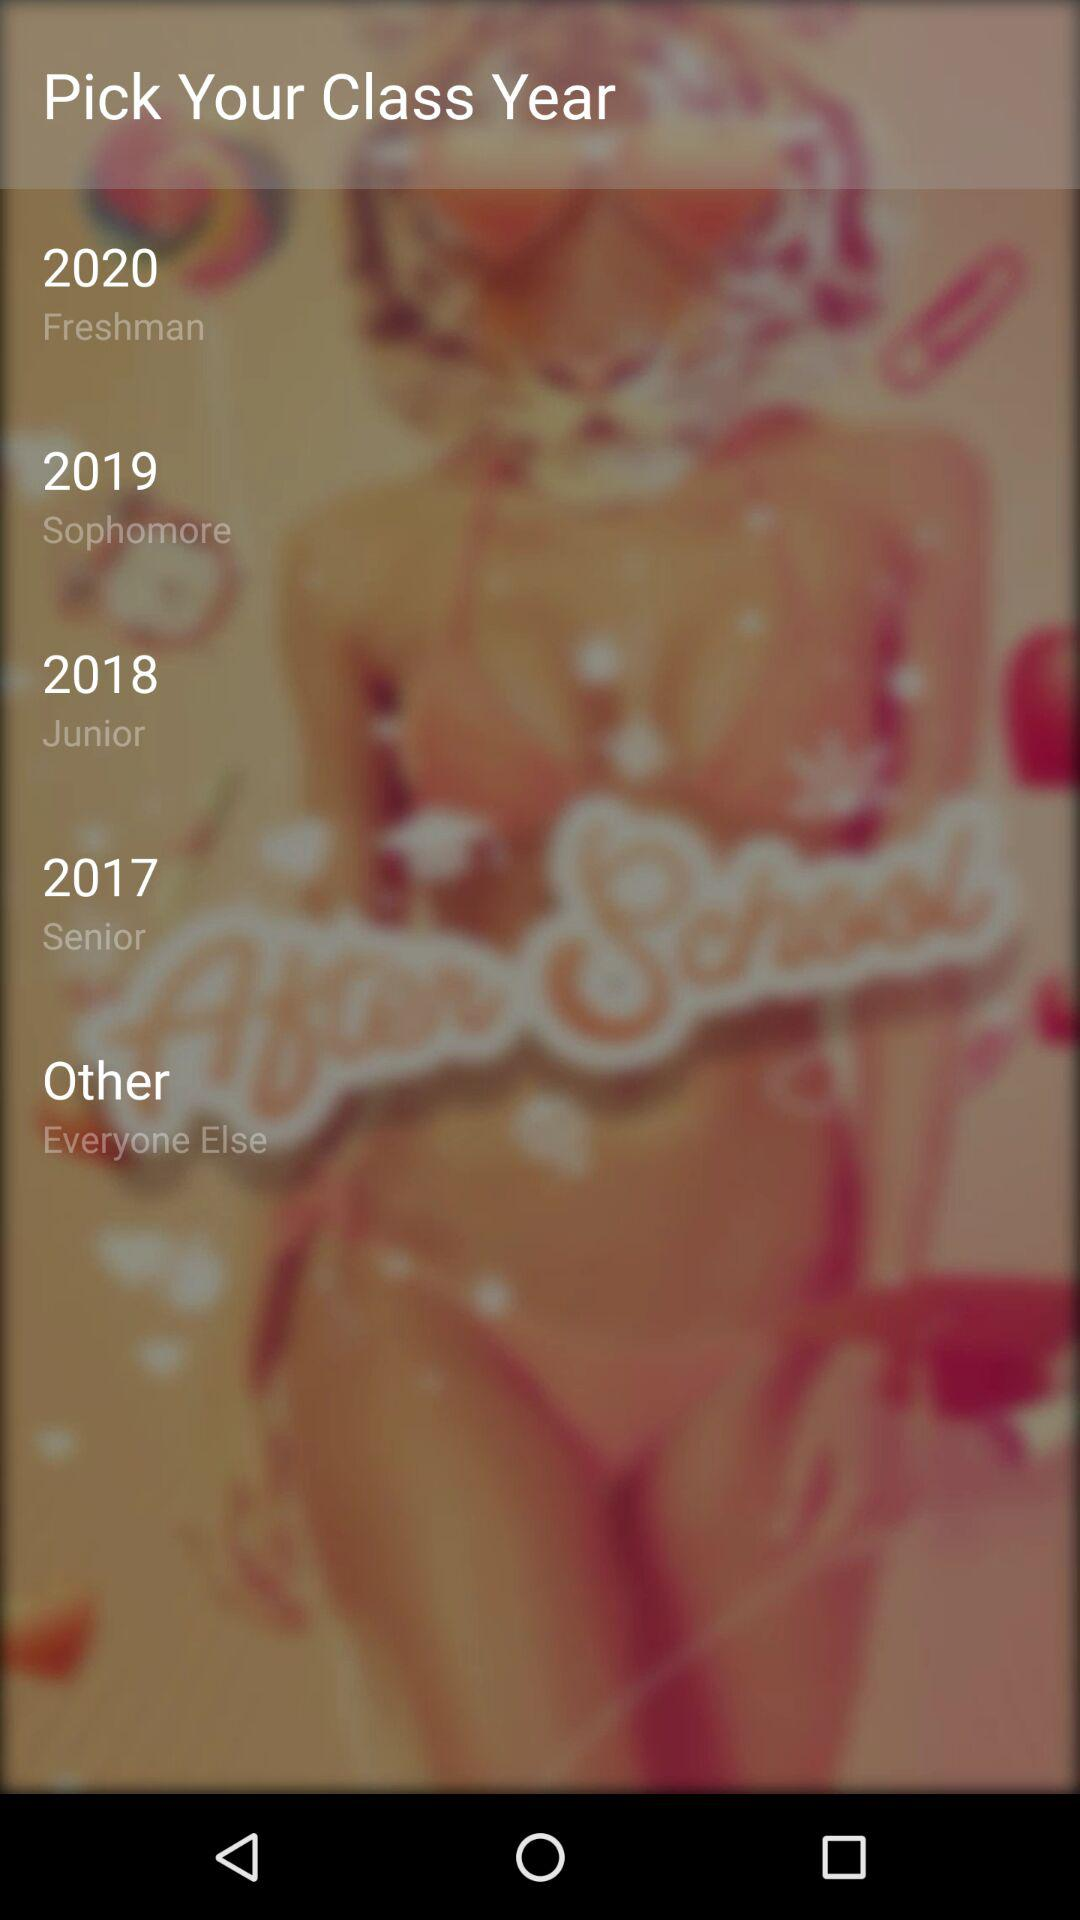Which class was in the year 2017? The class that was in the year 2017 is "Senior". 